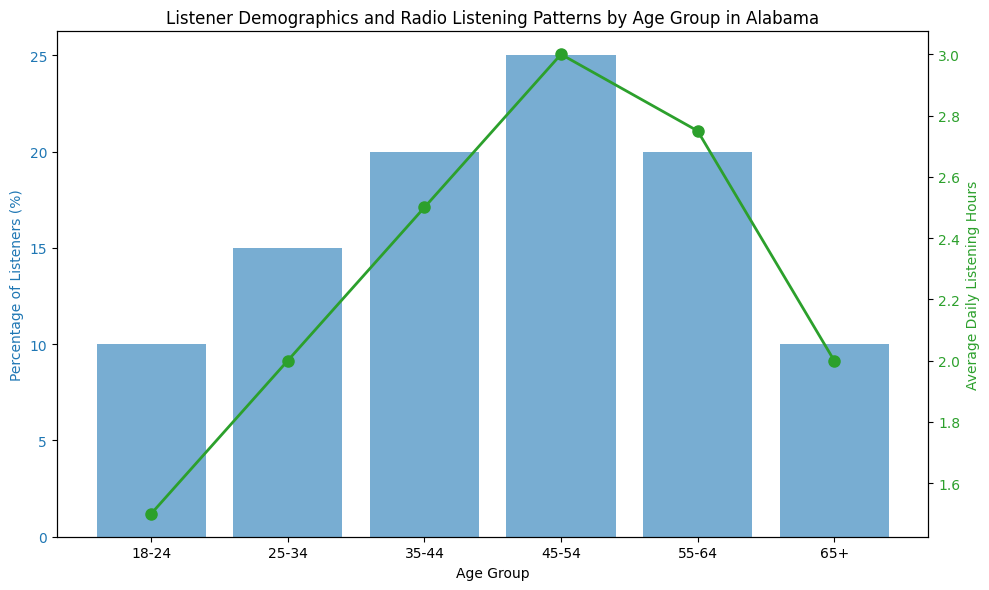What's the age group with the highest percentage of listeners? The bar with the greatest height corresponds to the 45-54 age group, indicating it has the highest percentage of listeners.
Answer: 45-54 Which age group listens to the radio the least, on average? The line graph shows that the 18-24 age group has the lowest point on average daily listening hours.
Answer: 18-24 What's the difference in average daily listening hours between the 45-54 and 55-64 age groups? The 45-54 age group averages 3 hours, and the 55-64 group averages 2.75 hours. The difference is 3 - 2.75 = 0.25 hours.
Answer: 0.25 Which age group has the same percentage of listeners as the 65+ group? The bar for the 18-24 age group has the same height as the bar for the 65+ group, both at 10%.
Answer: 18-24 What is the total percentage of listeners from the age groups 18-24 and 65+ combined? The percentage for 18-24 is 10%, and for 65+ it is 10%. The total is 10% + 10% = 20%.
Answer: 20% Between which two consecutive age groups does the average daily listening hours increase the most? The average daily listening hours increase from 2 to 2.5 hours between the 25-34 and 35-44 age groups, and by 0.5 hours, which is the largest increase between consecutive age groups.
Answer: 25-34 and 35-44 How much more do listeners aged 45-54 listen to the radio each day compared to those aged 25-34? The average daily listening hours for 45-54 is 3 hours, and for 25-34 is 2 hours. The difference is 3 - 2 = 1 hour.
Answer: 1 Which age group has the highest average daily listening hours? The peak of the green line shows that listeners aged 45-54 have the highest average daily listening hours at 3 hours.
Answer: 45-54 